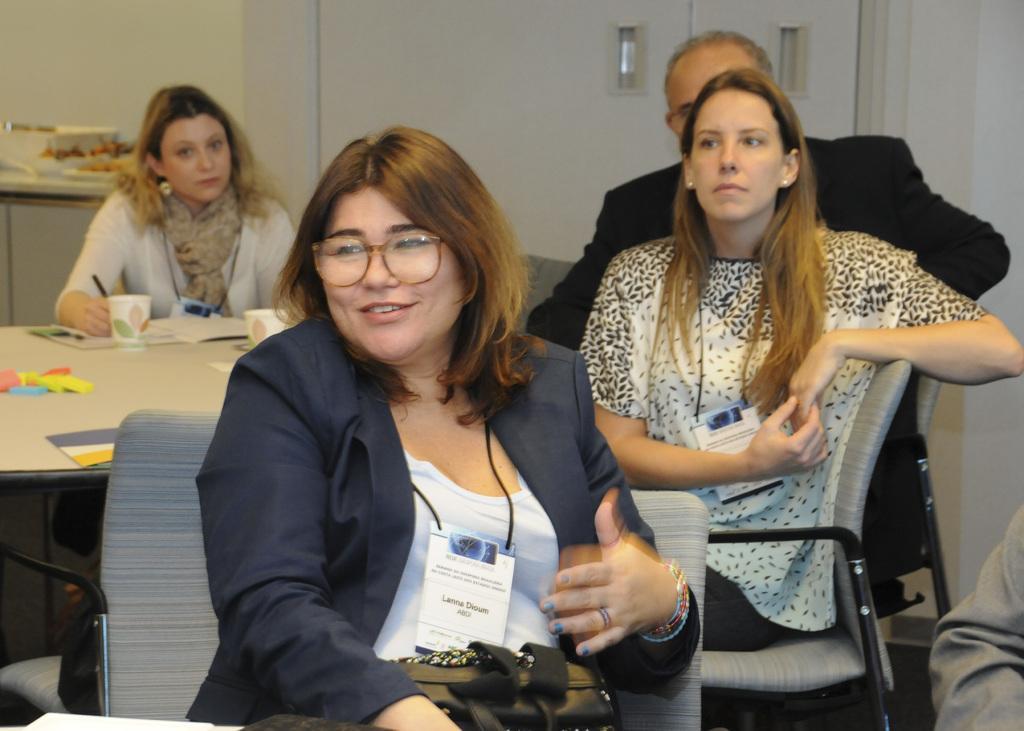Describe this image in one or two sentences. In this image there are people sitting on chairs, in the middle there is a table, on that table there are cups and books, in the background there is a wall for that wall there is a door. 